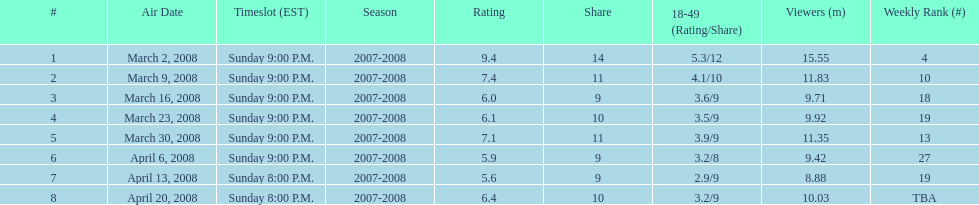Did the season finish at an earlier or later timeslot? Earlier. 